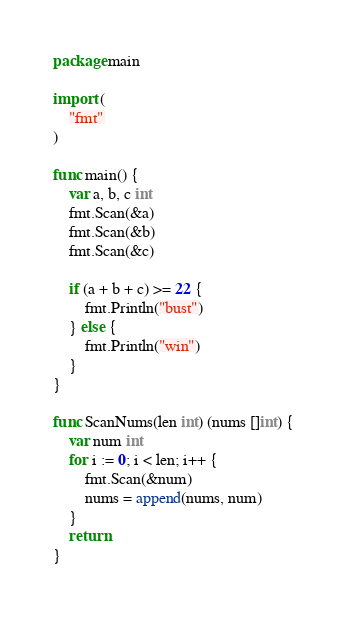<code> <loc_0><loc_0><loc_500><loc_500><_Go_>package main

import (
	"fmt"
)

func main() {
	var a, b, c int
	fmt.Scan(&a)
	fmt.Scan(&b)
	fmt.Scan(&c)

	if (a + b + c) >= 22 {
		fmt.Println("bust")
	} else {
		fmt.Println("win")
	}
}

func ScanNums(len int) (nums []int) {
	var num int
	for i := 0; i < len; i++ {
		fmt.Scan(&num)
		nums = append(nums, num)
	}
	return
}
</code> 